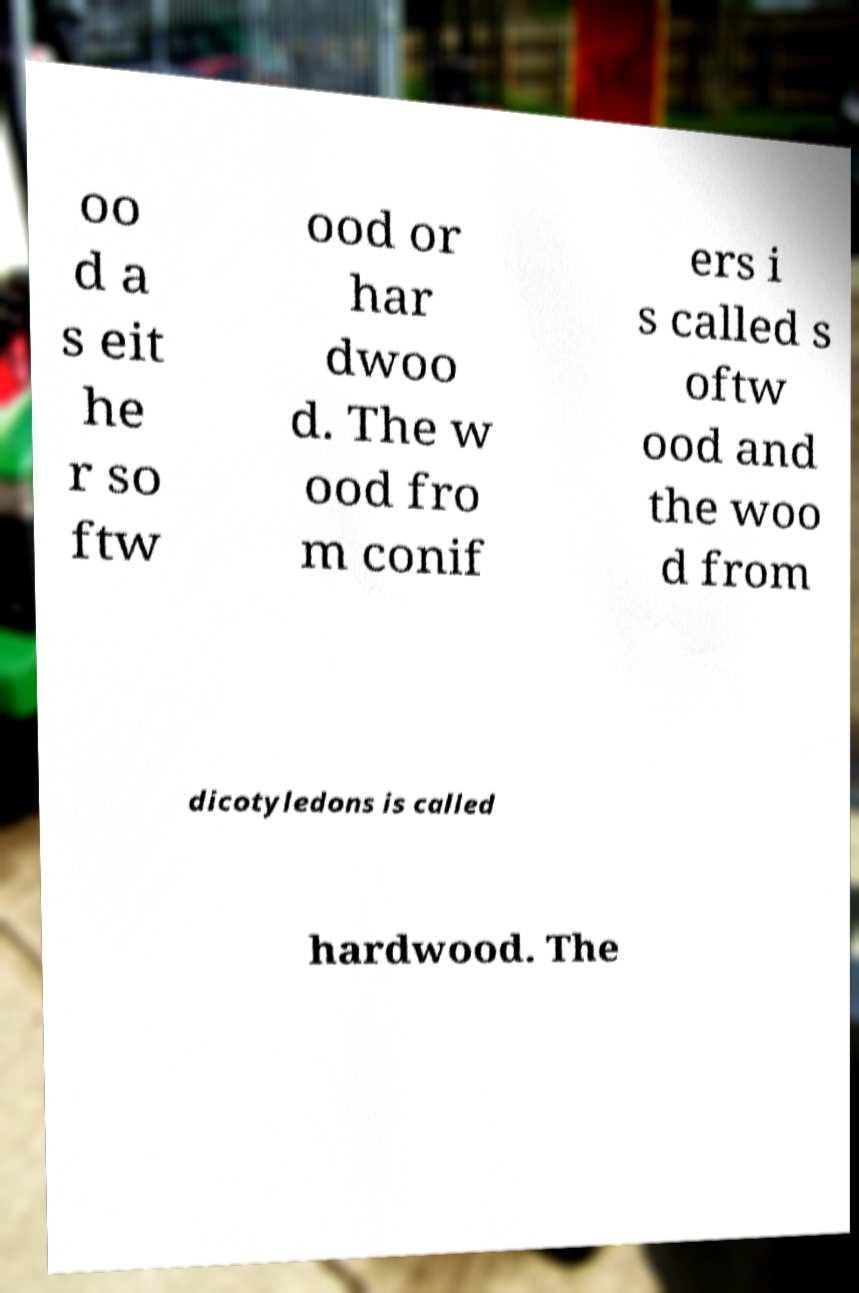For documentation purposes, I need the text within this image transcribed. Could you provide that? oo d a s eit he r so ftw ood or har dwoo d. The w ood fro m conif ers i s called s oftw ood and the woo d from dicotyledons is called hardwood. The 